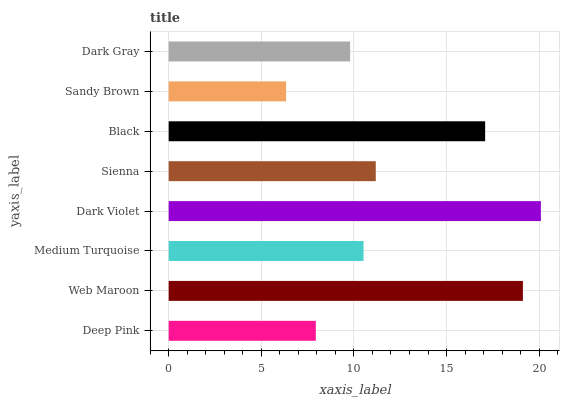Is Sandy Brown the minimum?
Answer yes or no. Yes. Is Dark Violet the maximum?
Answer yes or no. Yes. Is Web Maroon the minimum?
Answer yes or no. No. Is Web Maroon the maximum?
Answer yes or no. No. Is Web Maroon greater than Deep Pink?
Answer yes or no. Yes. Is Deep Pink less than Web Maroon?
Answer yes or no. Yes. Is Deep Pink greater than Web Maroon?
Answer yes or no. No. Is Web Maroon less than Deep Pink?
Answer yes or no. No. Is Sienna the high median?
Answer yes or no. Yes. Is Medium Turquoise the low median?
Answer yes or no. Yes. Is Web Maroon the high median?
Answer yes or no. No. Is Deep Pink the low median?
Answer yes or no. No. 